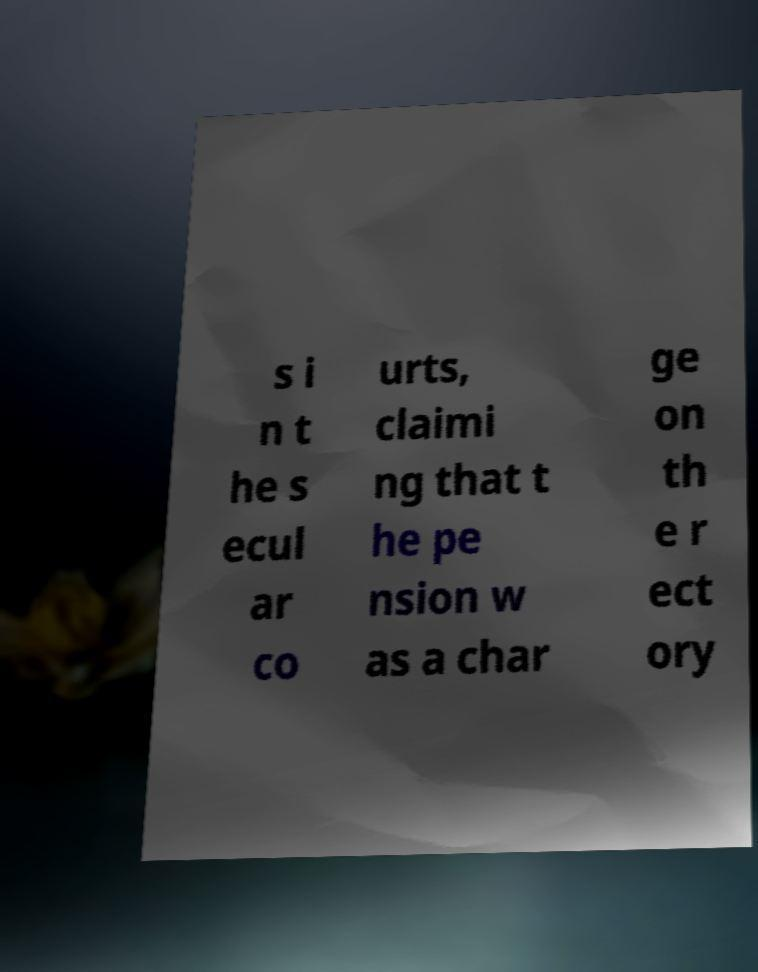I need the written content from this picture converted into text. Can you do that? s i n t he s ecul ar co urts, claimi ng that t he pe nsion w as a char ge on th e r ect ory 